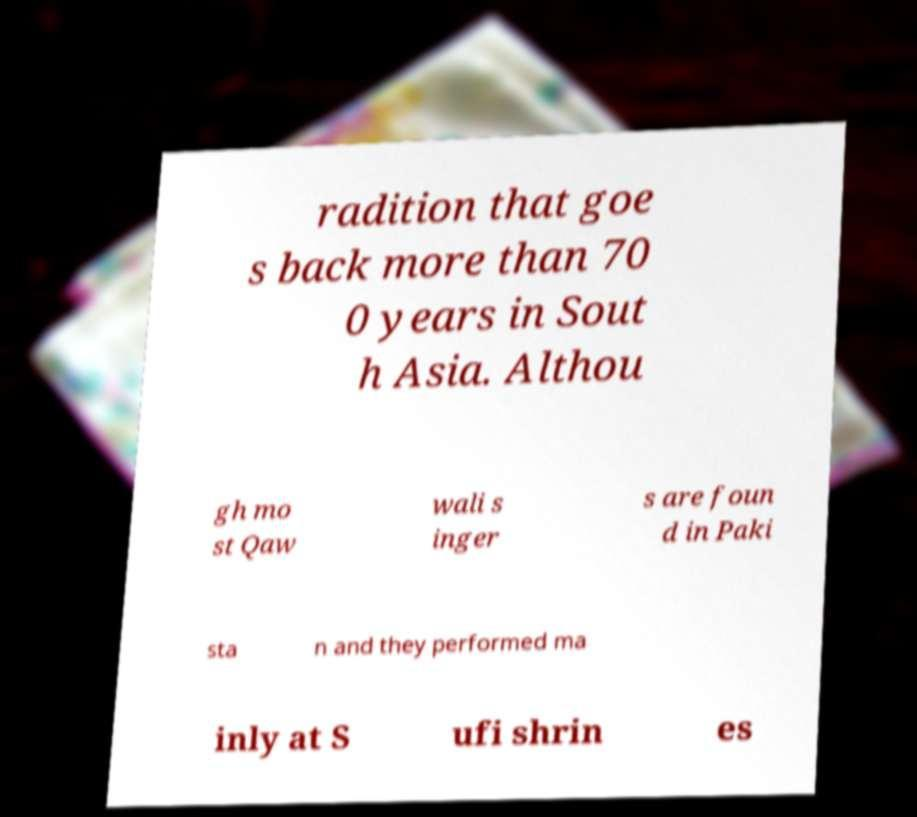Can you accurately transcribe the text from the provided image for me? radition that goe s back more than 70 0 years in Sout h Asia. Althou gh mo st Qaw wali s inger s are foun d in Paki sta n and they performed ma inly at S ufi shrin es 